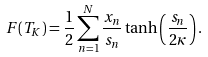Convert formula to latex. <formula><loc_0><loc_0><loc_500><loc_500>F ( T _ { K } ) = \frac { 1 } { 2 } \sum _ { n = 1 } ^ { N } \frac { x _ { n } } { s _ { n } } \tanh \left ( \frac { s _ { n } } { 2 \kappa } \right ) .</formula> 